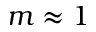Convert formula to latex. <formula><loc_0><loc_0><loc_500><loc_500>m \approx 1</formula> 